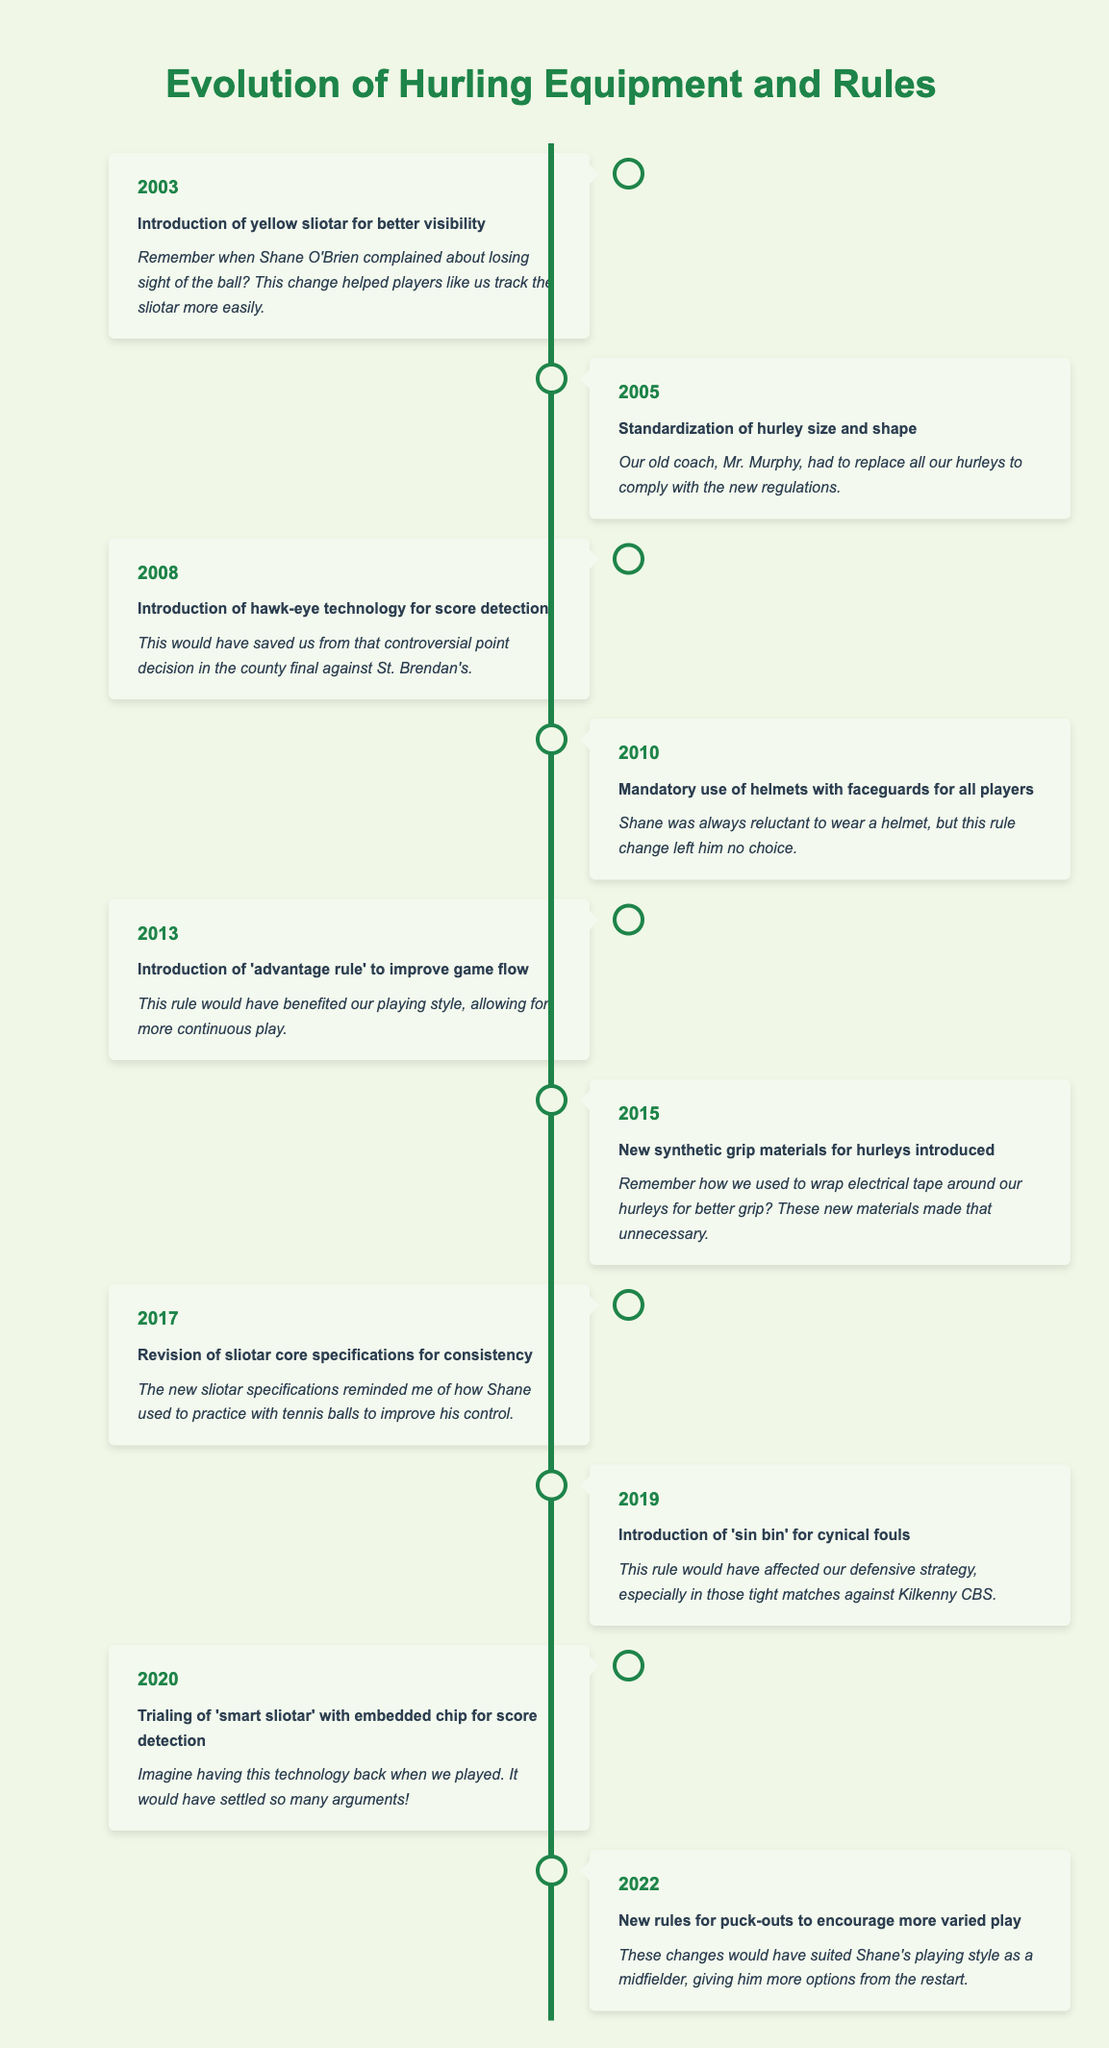What year was the introduction of the yellow sliotar for better visibility? The table lists the event along with its year. The introduction of the yellow sliotar is noted in the entry for 2003.
Answer: 2003 Which event occurred in 2015 regarding hurleys? The table indicates that in 2015, new synthetic grip materials for hurleys were introduced. This fact can be found directly in the respective entry.
Answer: New synthetic grip materials for hurleys introduced Was the 'sin bin' rule introduced before or after the mandatory use of helmets? To answer this, we look at the two events: the 'sin bin' rule was introduced in 2019, while the helmet mandate came in 2010. Since 2019 is after 2010, the 'sin bin' rule was introduced after the helmet mandate.
Answer: After In which years were significant changes related to the sliotar made? The timeline shows two specific events directly related to the sliotar: in 2003 (introduction of yellow sliotar) and 2017 (revision of sliotar core specifications). This indicates a focus on the sliotar in both years.
Answer: 2003 and 2017 How many years apart were the introduction of the 'advantage rule' and the 'sin bin'? The 'advantage rule' was introduced in 2013 and the 'sin bin' in 2019. The difference in years is 2019 - 2013 = 6 years.
Answer: 6 years Was helmet use optional before the rule was made mandatory in 2010? Prior to 2010, there was no mention in the table suggesting helmet use was mandatory, thus it implies that it was optional.
Answer: Yes Which event, according to the table, occurred in 2022? The event for 2022 is described as new rules for puck-outs aimed at encouraging more varied play. This is available in its respective entry.
Answer: New rules for puck-outs to encourage more varied play Was any technology introduced to help with score detection? The table shows that hawk-eye technology was introduced in 2008 for score detection, and in 2020, there was a trial of a 'smart sliotar' with an embedded chip for score detection, confirming that technology was indeed introduced for this purpose.
Answer: Yes Which changes were aimed at improving player safety? The mandatory use of helmets with faceguards in 2010 is a clear safety regulation introduced for all players. The table purely focuses on safety when noting this change.
Answer: Mandatory use of helmets with faceguards in 2010 